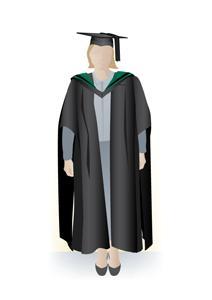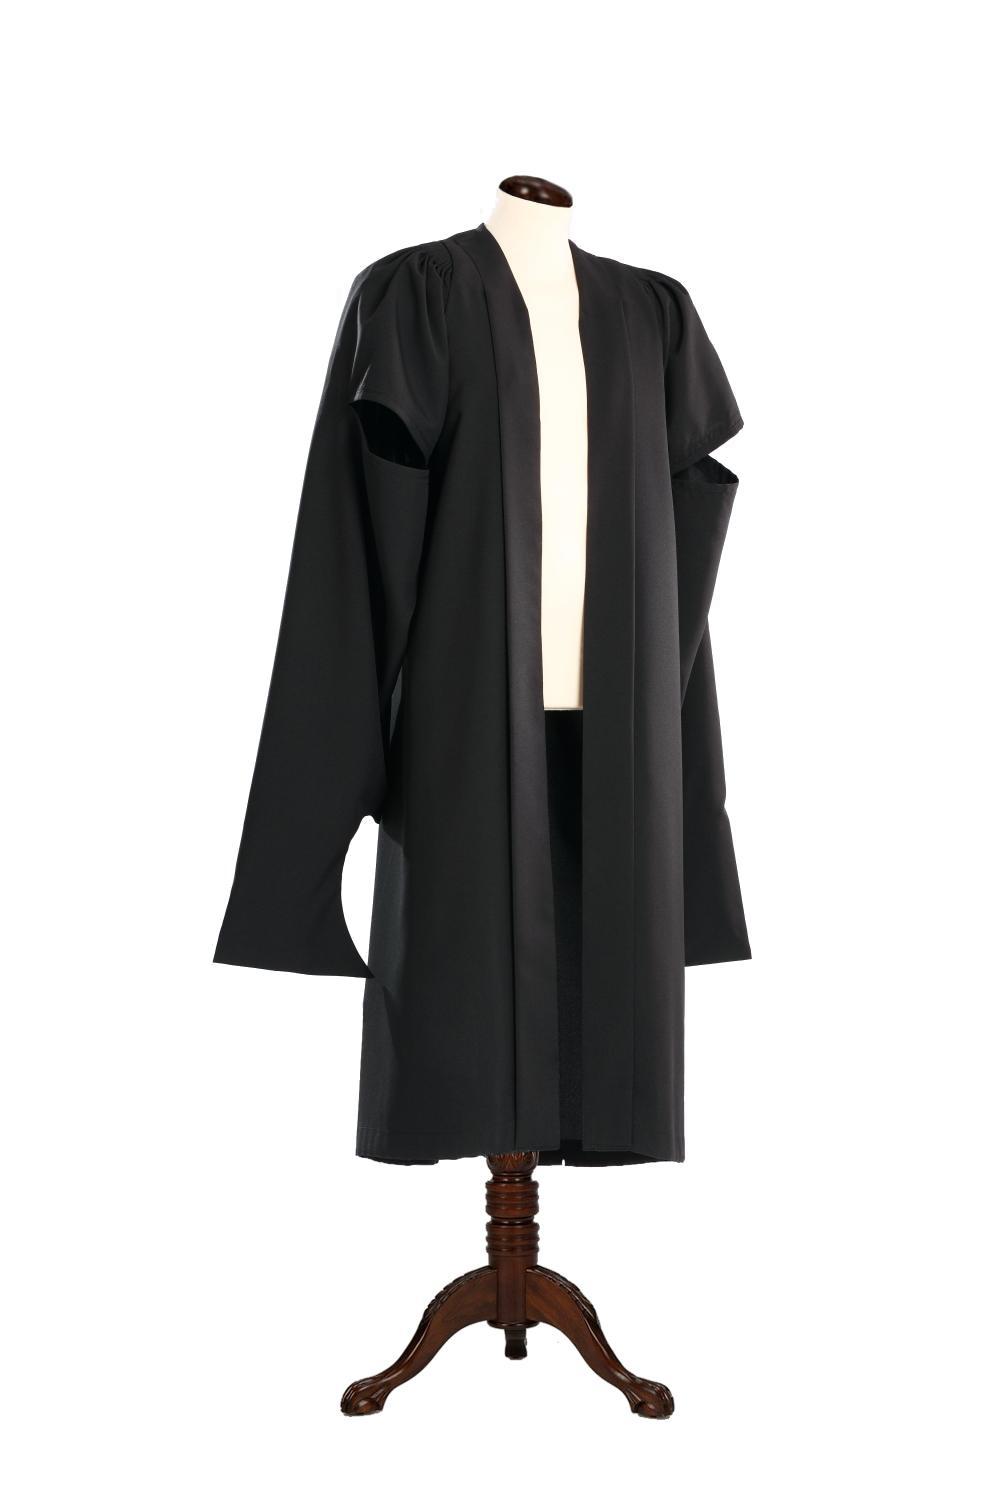The first image is the image on the left, the second image is the image on the right. Given the left and right images, does the statement "The left image contains at least 4 students in gowns, and you can see their entire body, head to foot." hold true? Answer yes or no. No. The first image is the image on the left, the second image is the image on the right. Analyze the images presented: Is the assertion "One photo has at least one male wearing a purple tie that is visible." valid? Answer yes or no. No. 